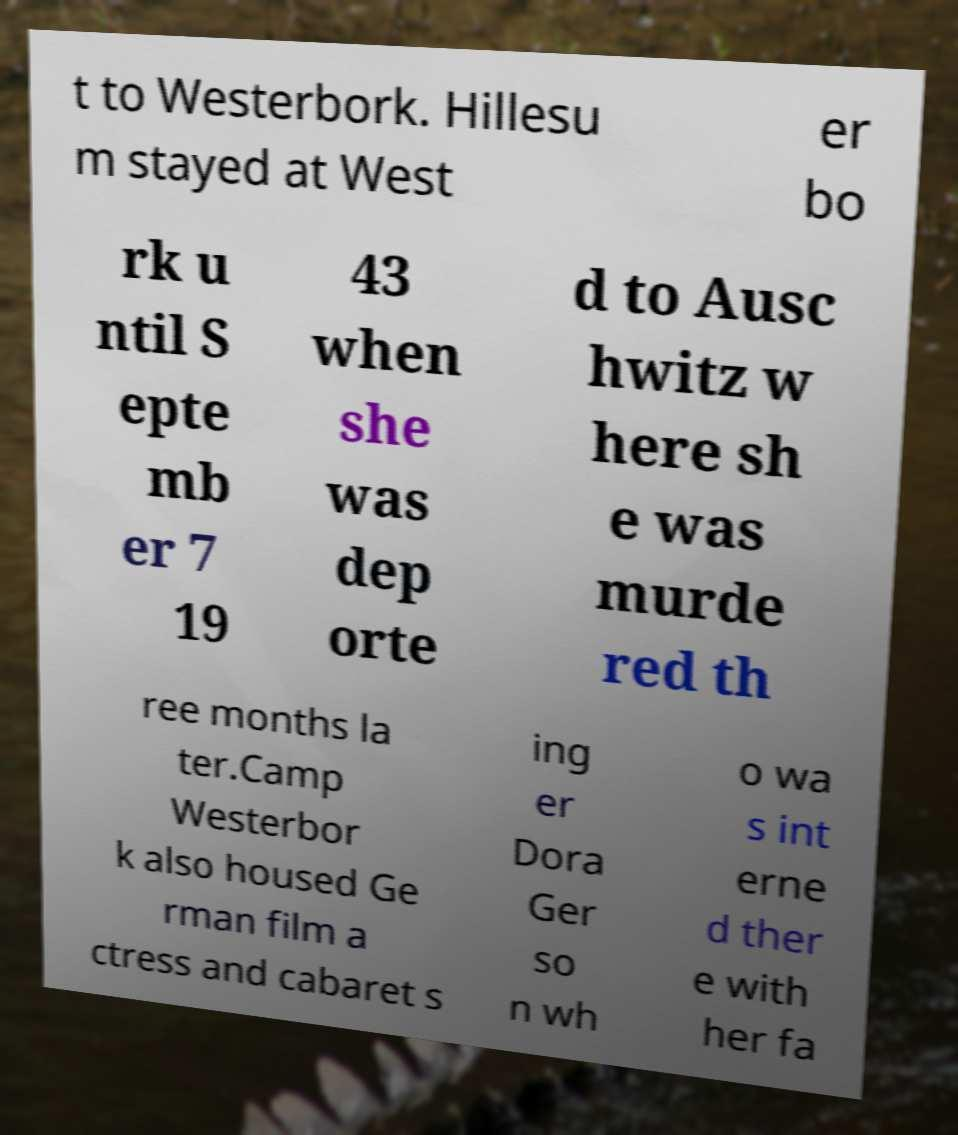Could you assist in decoding the text presented in this image and type it out clearly? t to Westerbork. Hillesu m stayed at West er bo rk u ntil S epte mb er 7 19 43 when she was dep orte d to Ausc hwitz w here sh e was murde red th ree months la ter.Camp Westerbor k also housed Ge rman film a ctress and cabaret s ing er Dora Ger so n wh o wa s int erne d ther e with her fa 